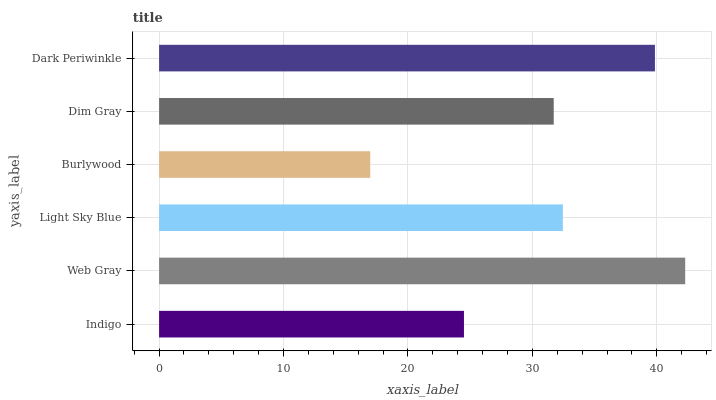Is Burlywood the minimum?
Answer yes or no. Yes. Is Web Gray the maximum?
Answer yes or no. Yes. Is Light Sky Blue the minimum?
Answer yes or no. No. Is Light Sky Blue the maximum?
Answer yes or no. No. Is Web Gray greater than Light Sky Blue?
Answer yes or no. Yes. Is Light Sky Blue less than Web Gray?
Answer yes or no. Yes. Is Light Sky Blue greater than Web Gray?
Answer yes or no. No. Is Web Gray less than Light Sky Blue?
Answer yes or no. No. Is Light Sky Blue the high median?
Answer yes or no. Yes. Is Dim Gray the low median?
Answer yes or no. Yes. Is Web Gray the high median?
Answer yes or no. No. Is Web Gray the low median?
Answer yes or no. No. 